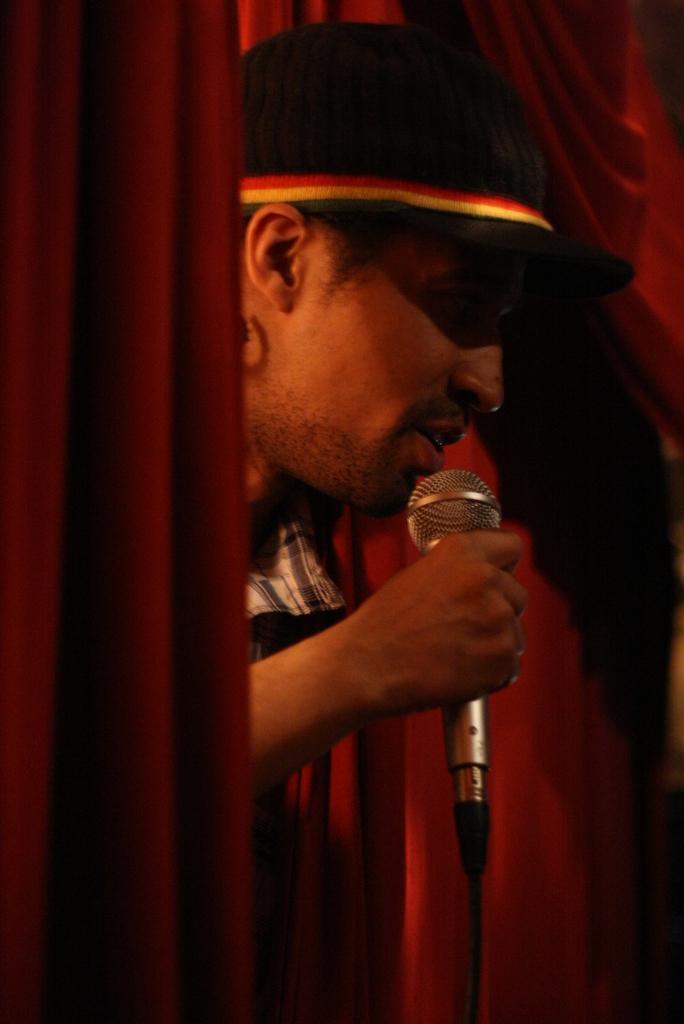Describe this image in one or two sentences. In this picture we can see clothes, cap and a man holding a mic with his hand. 